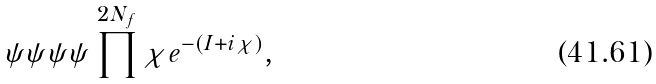<formula> <loc_0><loc_0><loc_500><loc_500>\psi \psi \psi \psi \prod ^ { 2 N _ { f } } \chi e ^ { - ( I + i \chi ) } ,</formula> 